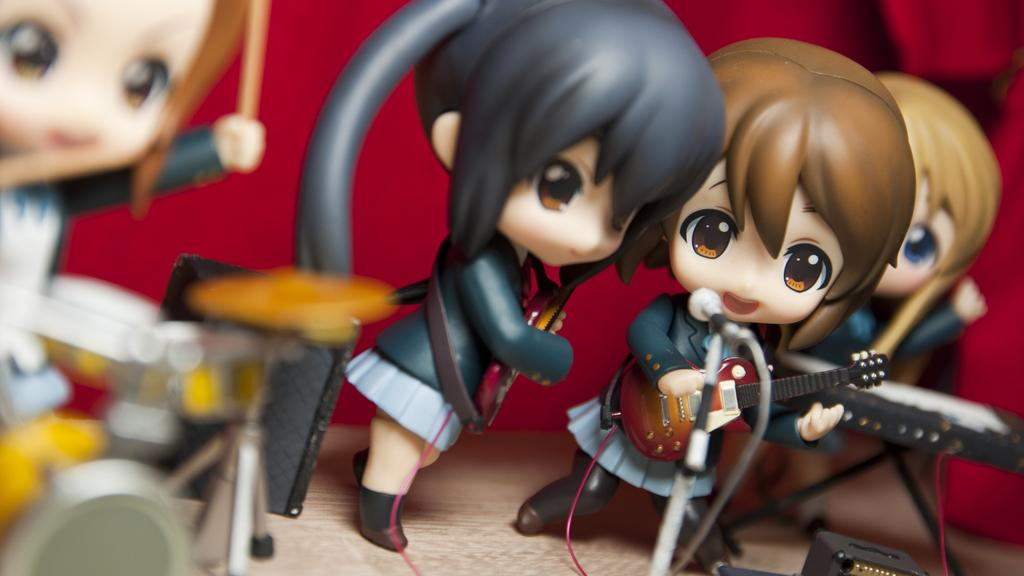How many dolls are present in the image? There are four women dolls in the image. What are the dolls doing in the image? The dolls are playing musical instruments. What type of scarecrow can be seen in the image? There is no scarecrow present in the image; it features four women dolls playing musical instruments. 